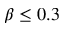Convert formula to latex. <formula><loc_0><loc_0><loc_500><loc_500>\beta \leq 0 . 3</formula> 